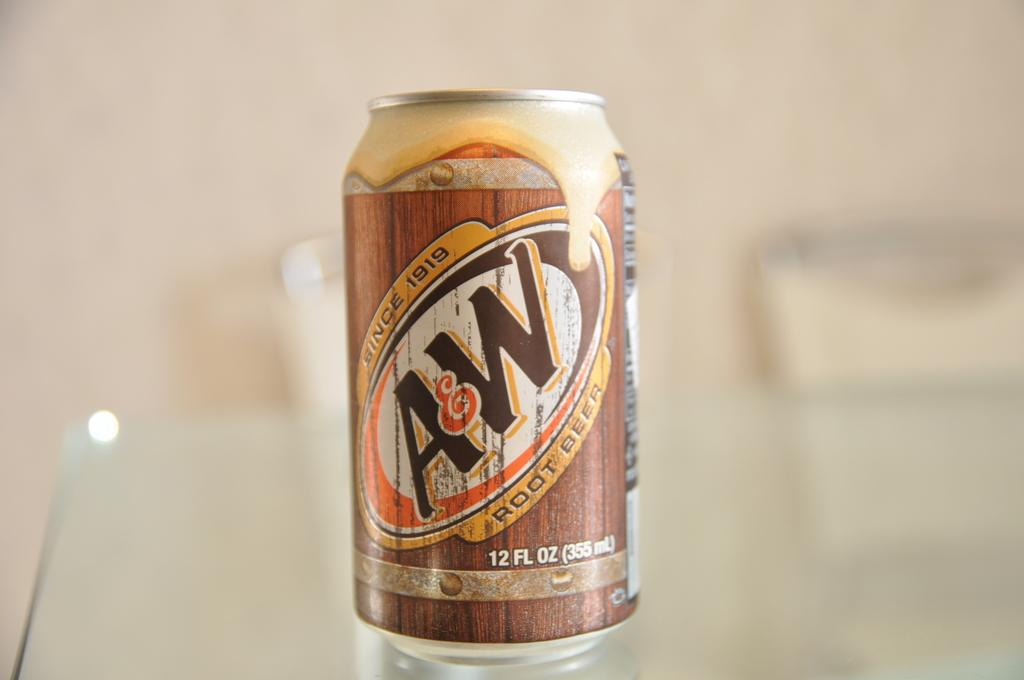<image>
Relay a brief, clear account of the picture shown. A&W root beer is a very tasty drink. 